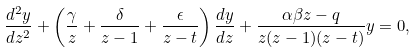Convert formula to latex. <formula><loc_0><loc_0><loc_500><loc_500>\frac { d ^ { 2 } y } { d z ^ { 2 } } + \left ( \frac { \gamma } { z } + \frac { \delta } { z - 1 } + \frac { \epsilon } { z - t } \right ) \frac { d y } { d z } + \frac { \alpha \beta z - q } { z ( z - 1 ) ( z - t ) } y = 0 ,</formula> 